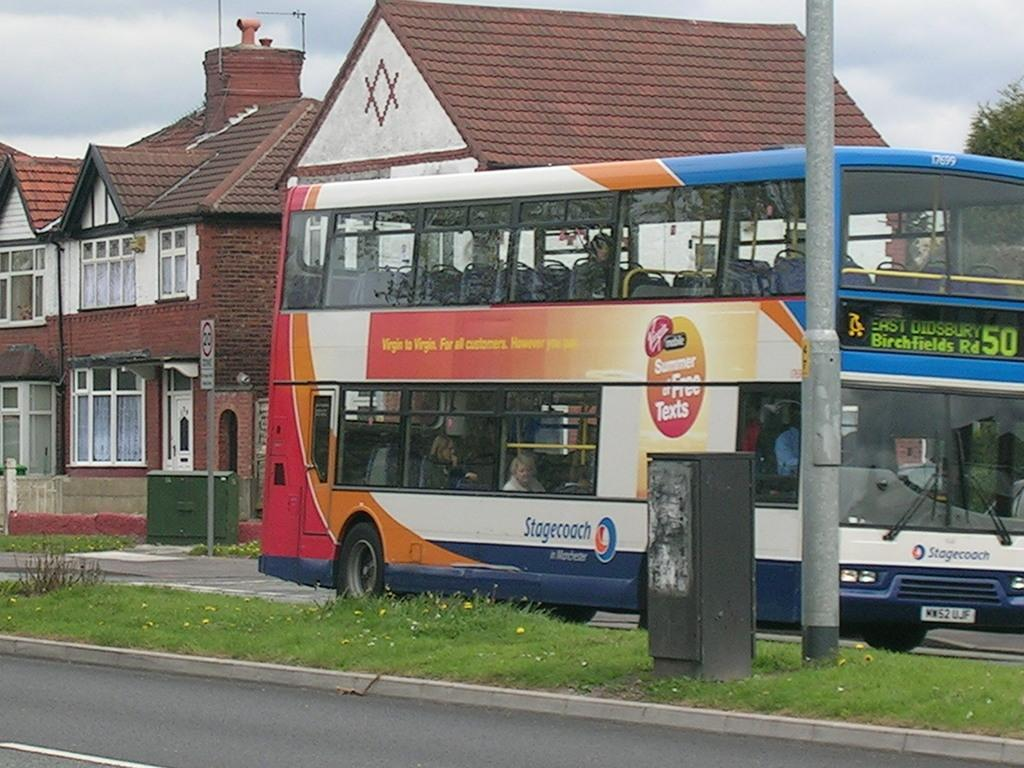<image>
Describe the image concisely. A Stagecoach brand double decker bus, number 50. 